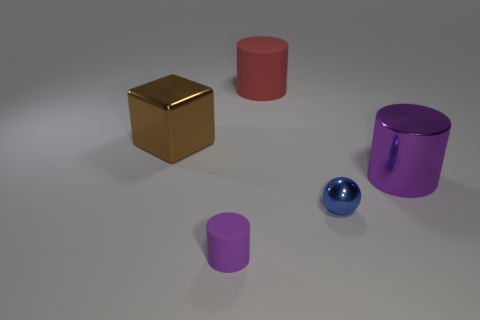Add 1 big purple objects. How many objects exist? 6 Subtract all spheres. How many objects are left? 4 Add 2 big metallic things. How many big metallic things are left? 4 Add 5 big yellow rubber cubes. How many big yellow rubber cubes exist? 5 Subtract 0 purple cubes. How many objects are left? 5 Subtract all big red cylinders. Subtract all red cylinders. How many objects are left? 3 